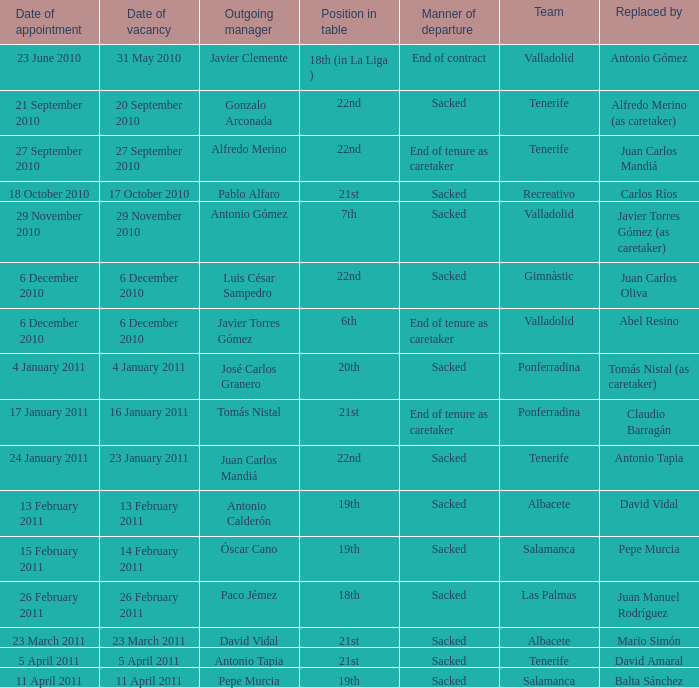How many teams had a departing manager of antonio gómez? 1.0. 